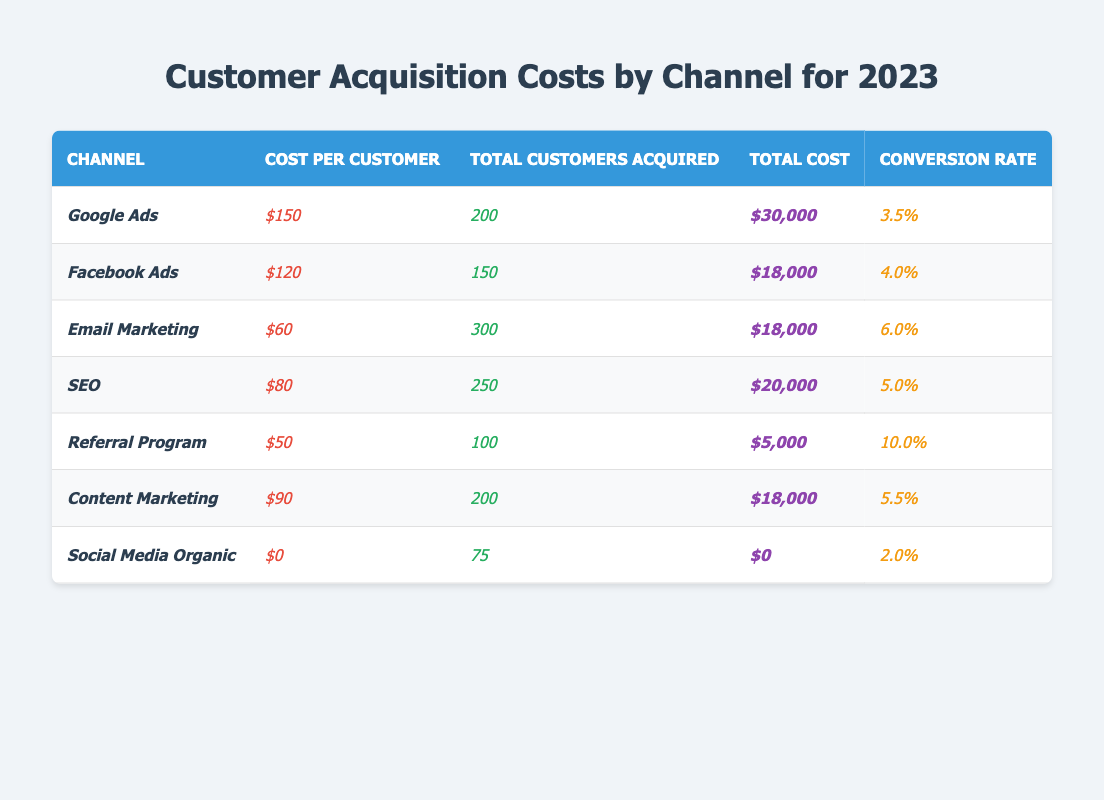What is the cost per customer for Google Ads? According to the table, the cost per customer for Google Ads is displayed in the corresponding row under the "Cost per Customer" column, which shows $150.
Answer: $150 What is the total number of customers acquired through the Referral Program? The table provides a specific value for the Referral Program in the "Total Customers Acquired" column, which states 100 customers were acquired.
Answer: 100 Which channel has the highest conversion rate? By comparing the "Conversion Rate" values across all channels, the Referral Program has the highest value at 10.0%, making it the channel with the highest conversion rate.
Answer: Referral Program What is the total cost associated with Email Marketing? Looking at the "Total Cost" column for Email Marketing in the table, it indicates that the total cost is $18,000.
Answer: $18,000 What is the average customer acquisition cost across all channels? To find the average, sum all the total costs ($30,000 + $18,000 + $18,000 + $20,000 + $5,000 + $18,000 + $0 = $109,000) and divide by the number of channels (7). The average is $109,000 / 7 = $15,571.43.
Answer: $15,571.43 Is the conversion rate for Social Media Organic higher than 3%? Referring to the "Conversion Rate" column, it shows that the conversion rate for Social Media Organic is 2.0%, which is lower than 3%. Therefore, the statement is false.
Answer: No What is the total cost incurred for channels with a cost per customer less than $100? Identify the relevant channels: Email Marketing ($18,000), SEO ($20,000), Referral Program ($5,000), and Social Media Organic ($0). Adding these gives $18,000 + $20,000 + $5,000 + $0 = $43,000.
Answer: $43,000 How many customers were acquired through SEO compared to Facebook Ads? The "Total Customers Acquired" for SEO is 250 and for Facebook Ads, it is 150. Comparing these numbers reveals that SEO acquired 100 more customers than Facebook Ads (250 - 150 = 100).
Answer: 100 more What percentage of the total customers acquired in 2023 came from Content Marketing? Total customers acquired are 200 (Google Ads) + 150 (Facebook Ads) + 300 (Email Marketing) + 250 (SEO) + 100 (Referral Program) + 200 (Content Marketing) + 75 (Social Media Organic) = 1,075. For Content Marketing, it acquired 200 customers, so the calculation is (200 / 1075) * 100 = 18.60%.
Answer: 18.60% What is the cost difference between the most expensive and the least expensive channel per customer? The most expensive is Google Ads at $150, and the least expensive is Social Media Organic at $0. The difference is $150 - $0 = $150.
Answer: $150 